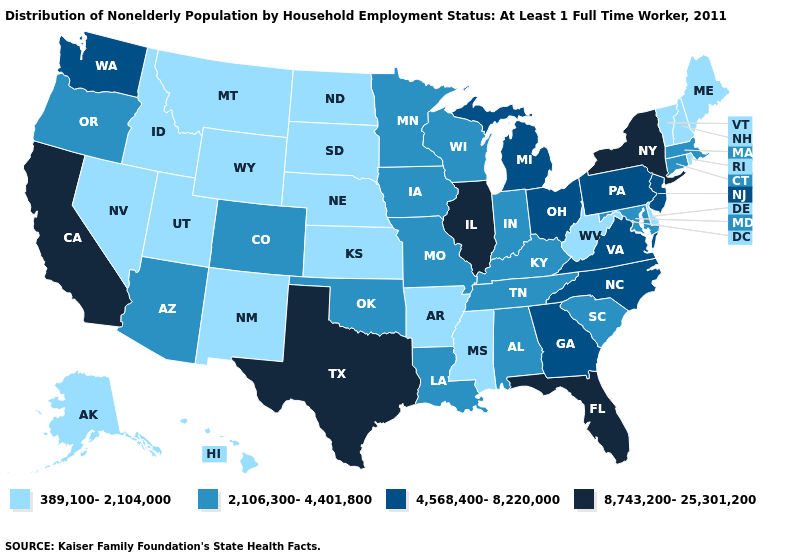Name the states that have a value in the range 4,568,400-8,220,000?
Short answer required. Georgia, Michigan, New Jersey, North Carolina, Ohio, Pennsylvania, Virginia, Washington. What is the value of Florida?
Give a very brief answer. 8,743,200-25,301,200. What is the value of Missouri?
Concise answer only. 2,106,300-4,401,800. Name the states that have a value in the range 8,743,200-25,301,200?
Write a very short answer. California, Florida, Illinois, New York, Texas. What is the highest value in the Northeast ?
Quick response, please. 8,743,200-25,301,200. What is the value of Texas?
Answer briefly. 8,743,200-25,301,200. Name the states that have a value in the range 8,743,200-25,301,200?
Write a very short answer. California, Florida, Illinois, New York, Texas. What is the value of Colorado?
Keep it brief. 2,106,300-4,401,800. What is the value of Arkansas?
Short answer required. 389,100-2,104,000. Does Wisconsin have the highest value in the MidWest?
Give a very brief answer. No. Name the states that have a value in the range 8,743,200-25,301,200?
Keep it brief. California, Florida, Illinois, New York, Texas. Does Louisiana have the same value as Iowa?
Write a very short answer. Yes. Name the states that have a value in the range 389,100-2,104,000?
Quick response, please. Alaska, Arkansas, Delaware, Hawaii, Idaho, Kansas, Maine, Mississippi, Montana, Nebraska, Nevada, New Hampshire, New Mexico, North Dakota, Rhode Island, South Dakota, Utah, Vermont, West Virginia, Wyoming. Name the states that have a value in the range 389,100-2,104,000?
Quick response, please. Alaska, Arkansas, Delaware, Hawaii, Idaho, Kansas, Maine, Mississippi, Montana, Nebraska, Nevada, New Hampshire, New Mexico, North Dakota, Rhode Island, South Dakota, Utah, Vermont, West Virginia, Wyoming. What is the lowest value in the USA?
Short answer required. 389,100-2,104,000. 